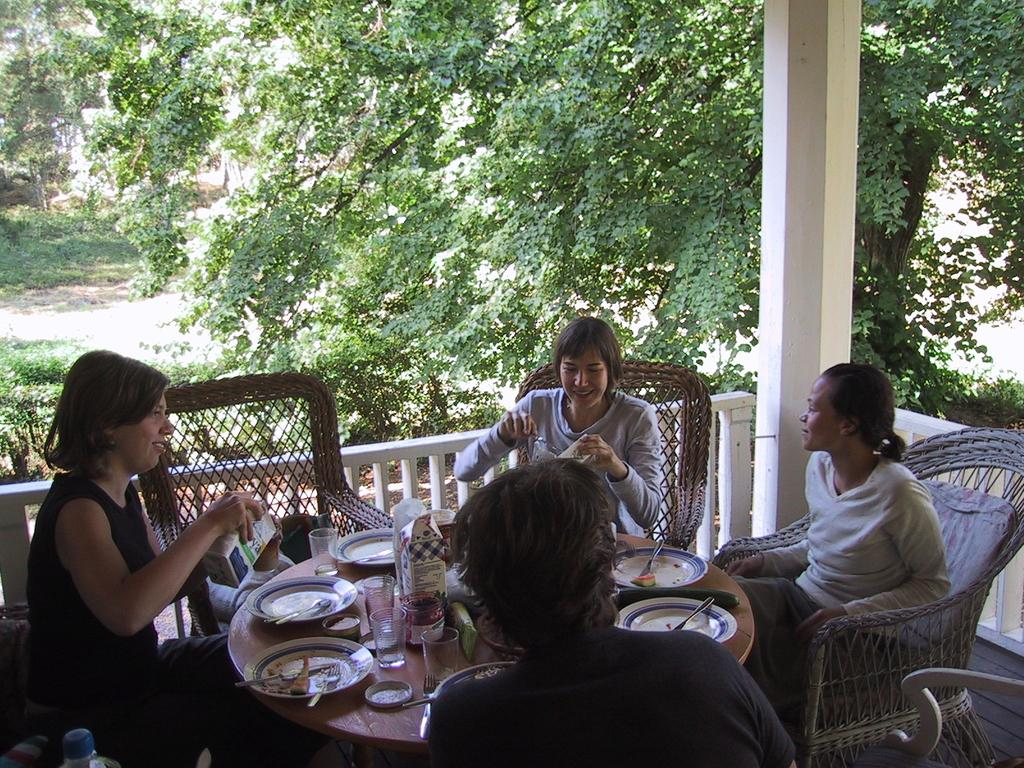What type of vegetation can be seen in the image? There are trees in the image. How many people are sitting in the image? There are four people sitting on chairs in the image. What is in front of the chairs? There is a table in front of the chairs. What items are on the table? There are glasses and plates on the table. Can you hear the sound of a crib in the image? There is no crib present in the image, and therefore no sound can be heard. Is this a picture of someone's home? The provided facts do not indicate whether the image is of a home or not. 